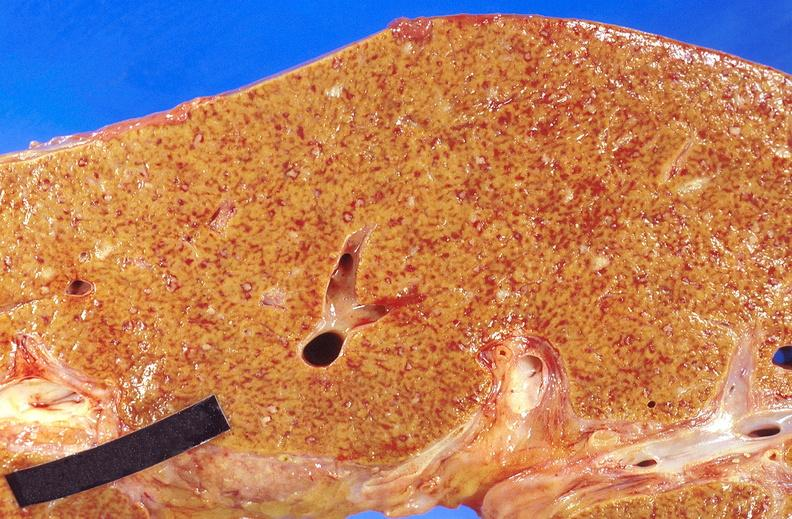s malignant adenoma present?
Answer the question using a single word or phrase. No 